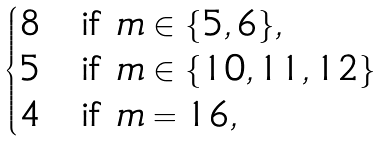Convert formula to latex. <formula><loc_0><loc_0><loc_500><loc_500>\begin{cases} 8 & \text {if $m\in\{5,6\} $} , \\ 5 & \text {if $m\in\{10,11,12\} $} \\ 4 & \text {if $m=16$} , \end{cases}</formula> 